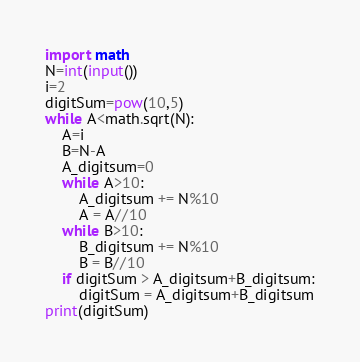Convert code to text. <code><loc_0><loc_0><loc_500><loc_500><_Python_>import math
N=int(input())
i=2
digitSum=pow(10,5)
while A<math.sqrt(N):
    A=i
    B=N-A
    A_digitsum=0
    while A>10:
        A_digitsum += N%10
        A = A//10
    while B>10:
        B_digitsum += N%10
        B = B//10
    if digitSum > A_digitsum+B_digitsum:
        digitSum = A_digitsum+B_digitsum
print(digitSum)</code> 